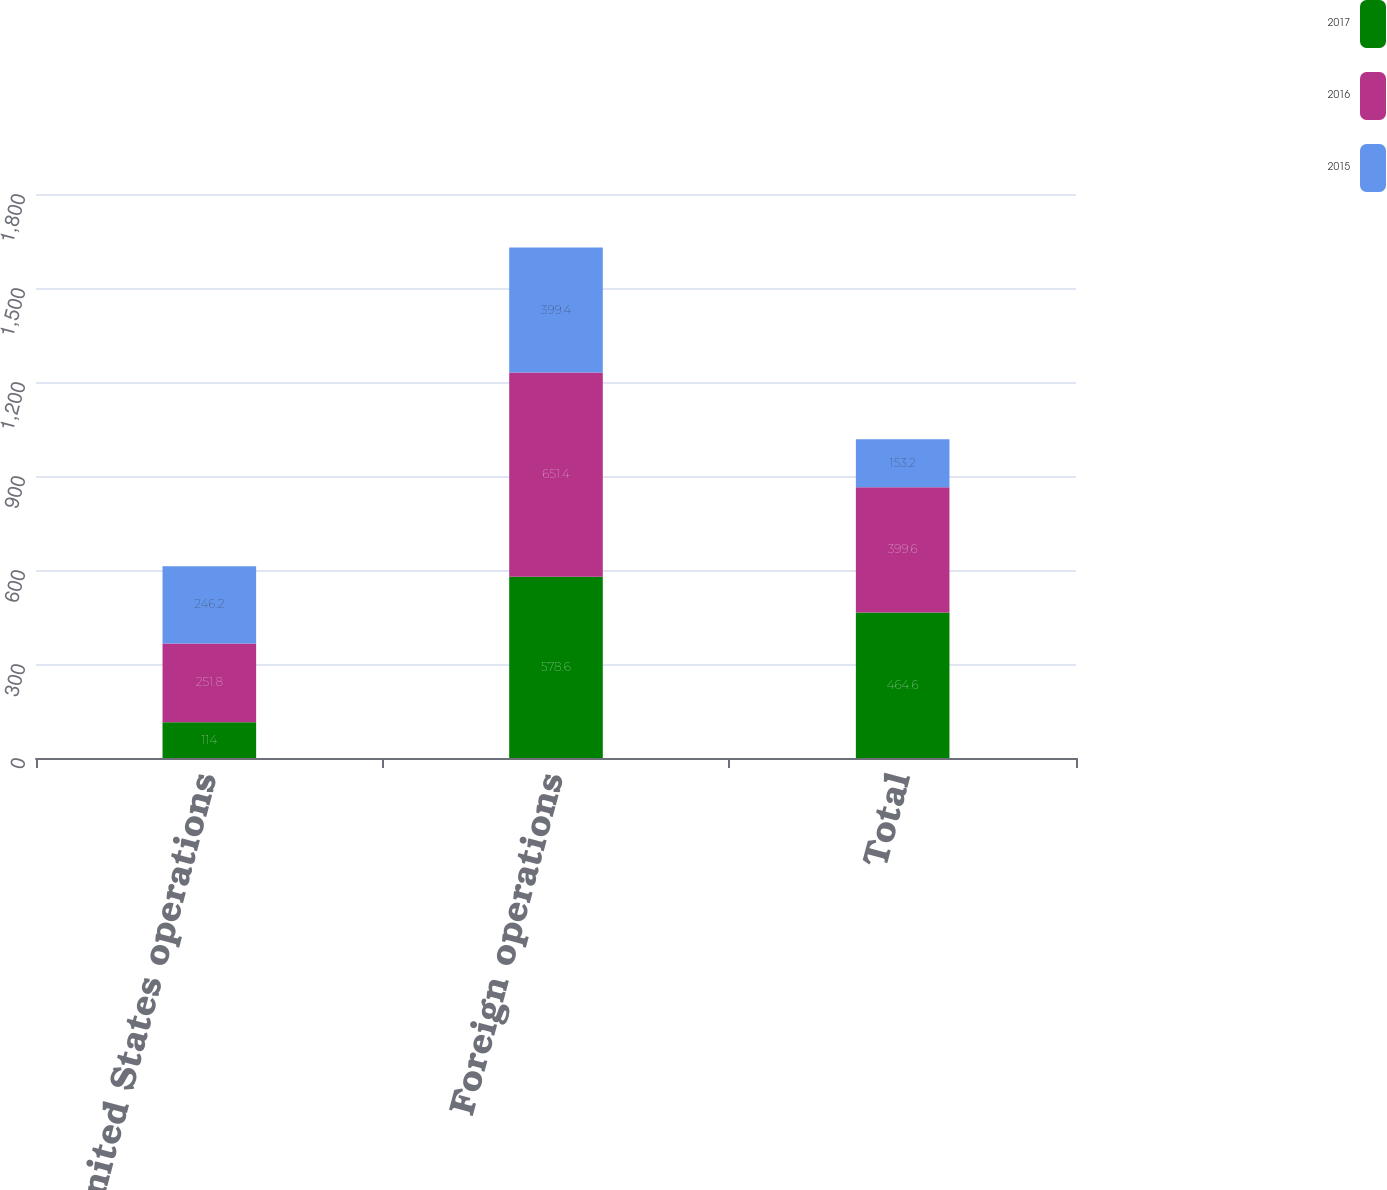<chart> <loc_0><loc_0><loc_500><loc_500><stacked_bar_chart><ecel><fcel>United States operations<fcel>Foreign operations<fcel>Total<nl><fcel>2017<fcel>114<fcel>578.6<fcel>464.6<nl><fcel>2016<fcel>251.8<fcel>651.4<fcel>399.6<nl><fcel>2015<fcel>246.2<fcel>399.4<fcel>153.2<nl></chart> 